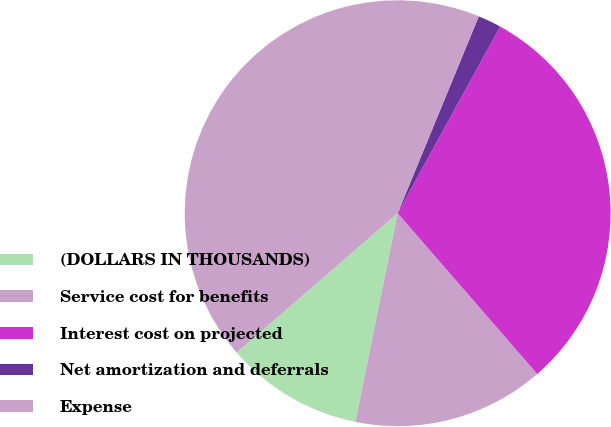<chart> <loc_0><loc_0><loc_500><loc_500><pie_chart><fcel>(DOLLARS IN THOUSANDS)<fcel>Service cost for benefits<fcel>Interest cost on projected<fcel>Net amortization and deferrals<fcel>Expense<nl><fcel>10.47%<fcel>14.55%<fcel>30.63%<fcel>1.77%<fcel>42.57%<nl></chart> 